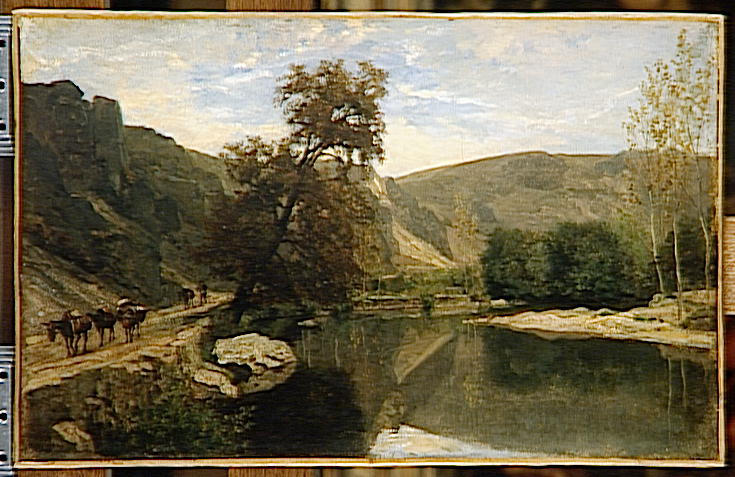Describe the painting from the perspective of one of the cows. As a cow, the painting would seem vast and filled with the essential elements of a simple, content life. The gently flowing river is not just a picturesque feature; it's a refreshing source of water. The lush green grass on the banks is the perfect location for leisurely grazing. The towering cliffs and trees provide much-needed shade and protection. The path along the river is familiar, a route often taken alongside the farmer, offering a sense of comfort and routine. How do you think the environment changes with the seasons? In spring, the valley awakens with vibrant blooms and the renewed murmur of the stream swollen by melting snow. Summer brings richly green foliage and a bustling, energetic life along the riverbanks. Come autumn, the leaves transform to a tapestry of reds, oranges, and yellows, and the air cools, creating a crisp, invigorating atmosphere. Winter covers the landscape in a quiet, white blanket of snow, with the stream partially frozen, and the surroundings becoming serene and still, a stark yet beautiful transformation of the lively scene. 